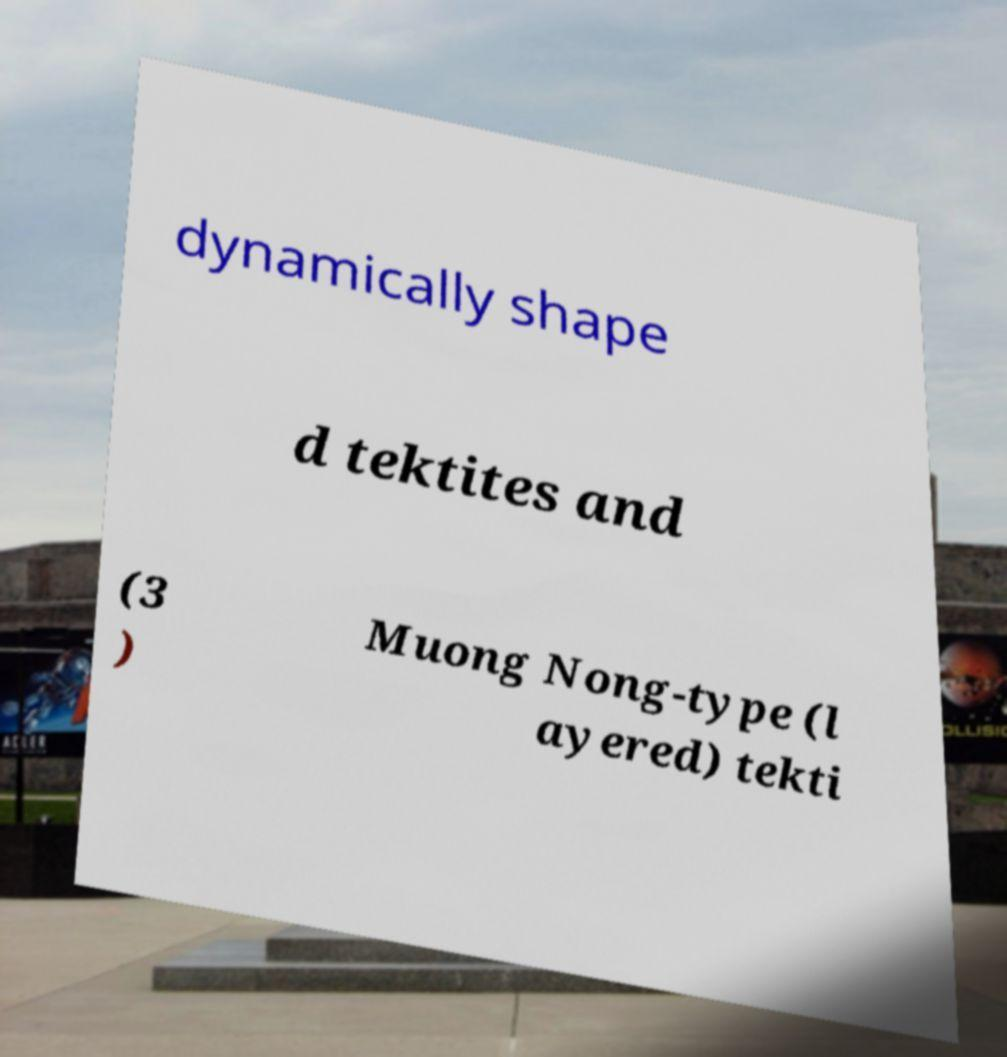Can you accurately transcribe the text from the provided image for me? dynamically shape d tektites and (3 ) Muong Nong-type (l ayered) tekti 